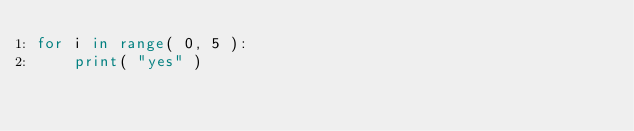<code> <loc_0><loc_0><loc_500><loc_500><_Python_>for i in range( 0, 5 ):
	print( "yes" )</code> 